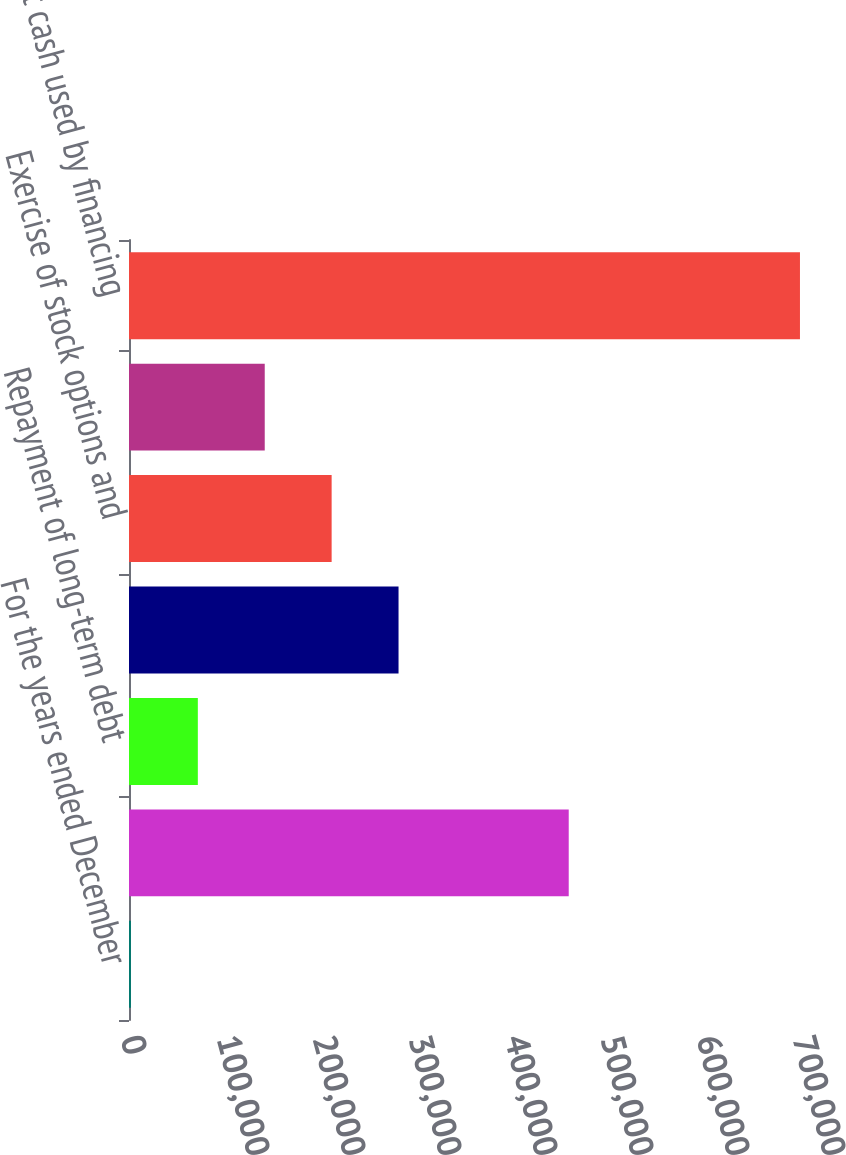Convert chart. <chart><loc_0><loc_0><loc_500><loc_500><bar_chart><fcel>For the years ended December<fcel>Net change in short-term<fcel>Repayment of long-term debt<fcel>Cash dividends paid<fcel>Exercise of stock options and<fcel>Repurchase of Common Stock<fcel>Net cash used by financing<nl><fcel>2009<fcel>458047<fcel>71700.2<fcel>280774<fcel>211083<fcel>141391<fcel>698921<nl></chart> 